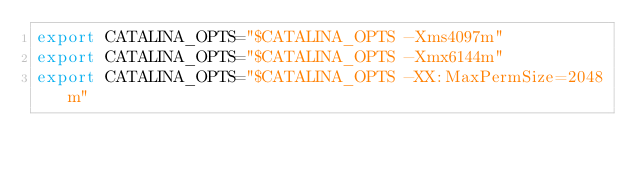Convert code to text. <code><loc_0><loc_0><loc_500><loc_500><_Bash_>export CATALINA_OPTS="$CATALINA_OPTS -Xms4097m"
export CATALINA_OPTS="$CATALINA_OPTS -Xmx6144m"
export CATALINA_OPTS="$CATALINA_OPTS -XX:MaxPermSize=2048m"

</code> 